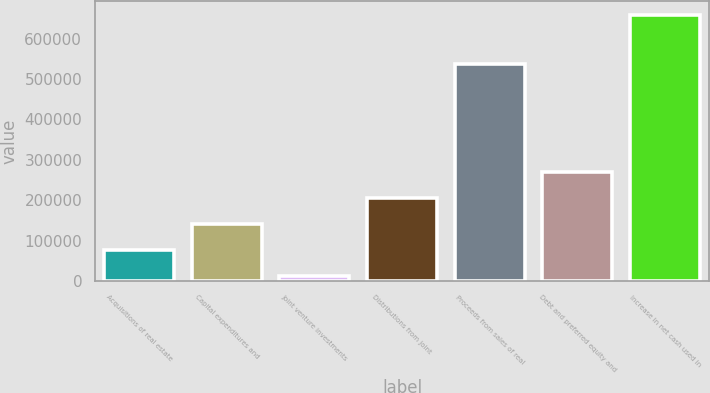Convert chart to OTSL. <chart><loc_0><loc_0><loc_500><loc_500><bar_chart><fcel>Acquisitions of real estate<fcel>Capital expenditures and<fcel>Joint venture investments<fcel>Distributions from joint<fcel>Proceeds from sales of real<fcel>Debt and preferred equity and<fcel>Increase in net cash used in<nl><fcel>76026.8<fcel>140874<fcel>11180<fcel>205720<fcel>538208<fcel>270567<fcel>659648<nl></chart> 